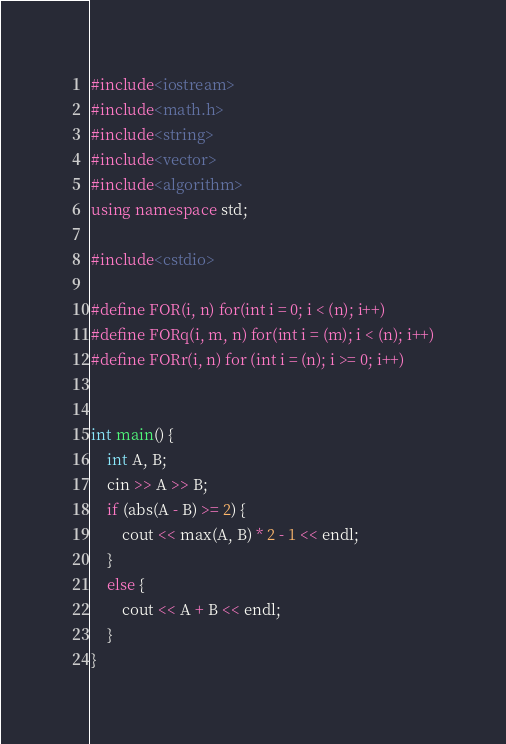<code> <loc_0><loc_0><loc_500><loc_500><_C++_>#include<iostream>
#include<math.h>
#include<string>
#include<vector>
#include<algorithm>
using namespace std;

#include<cstdio>

#define FOR(i, n) for(int i = 0; i < (n); i++)
#define FORq(i, m, n) for(int i = (m); i < (n); i++)
#define FORr(i, n) for (int i = (n); i >= 0; i++)


int main() {
	int A, B;
	cin >> A >> B;
	if (abs(A - B) >= 2) {
		cout << max(A, B) * 2 - 1 << endl;
	}
	else {
		cout << A + B << endl;
	}
}</code> 